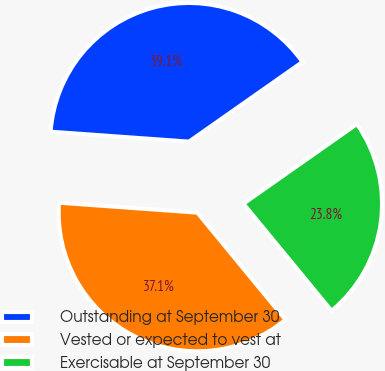Convert chart to OTSL. <chart><loc_0><loc_0><loc_500><loc_500><pie_chart><fcel>Outstanding at September 30<fcel>Vested or expected to vest at<fcel>Exercisable at September 30<nl><fcel>39.12%<fcel>37.1%<fcel>23.78%<nl></chart> 